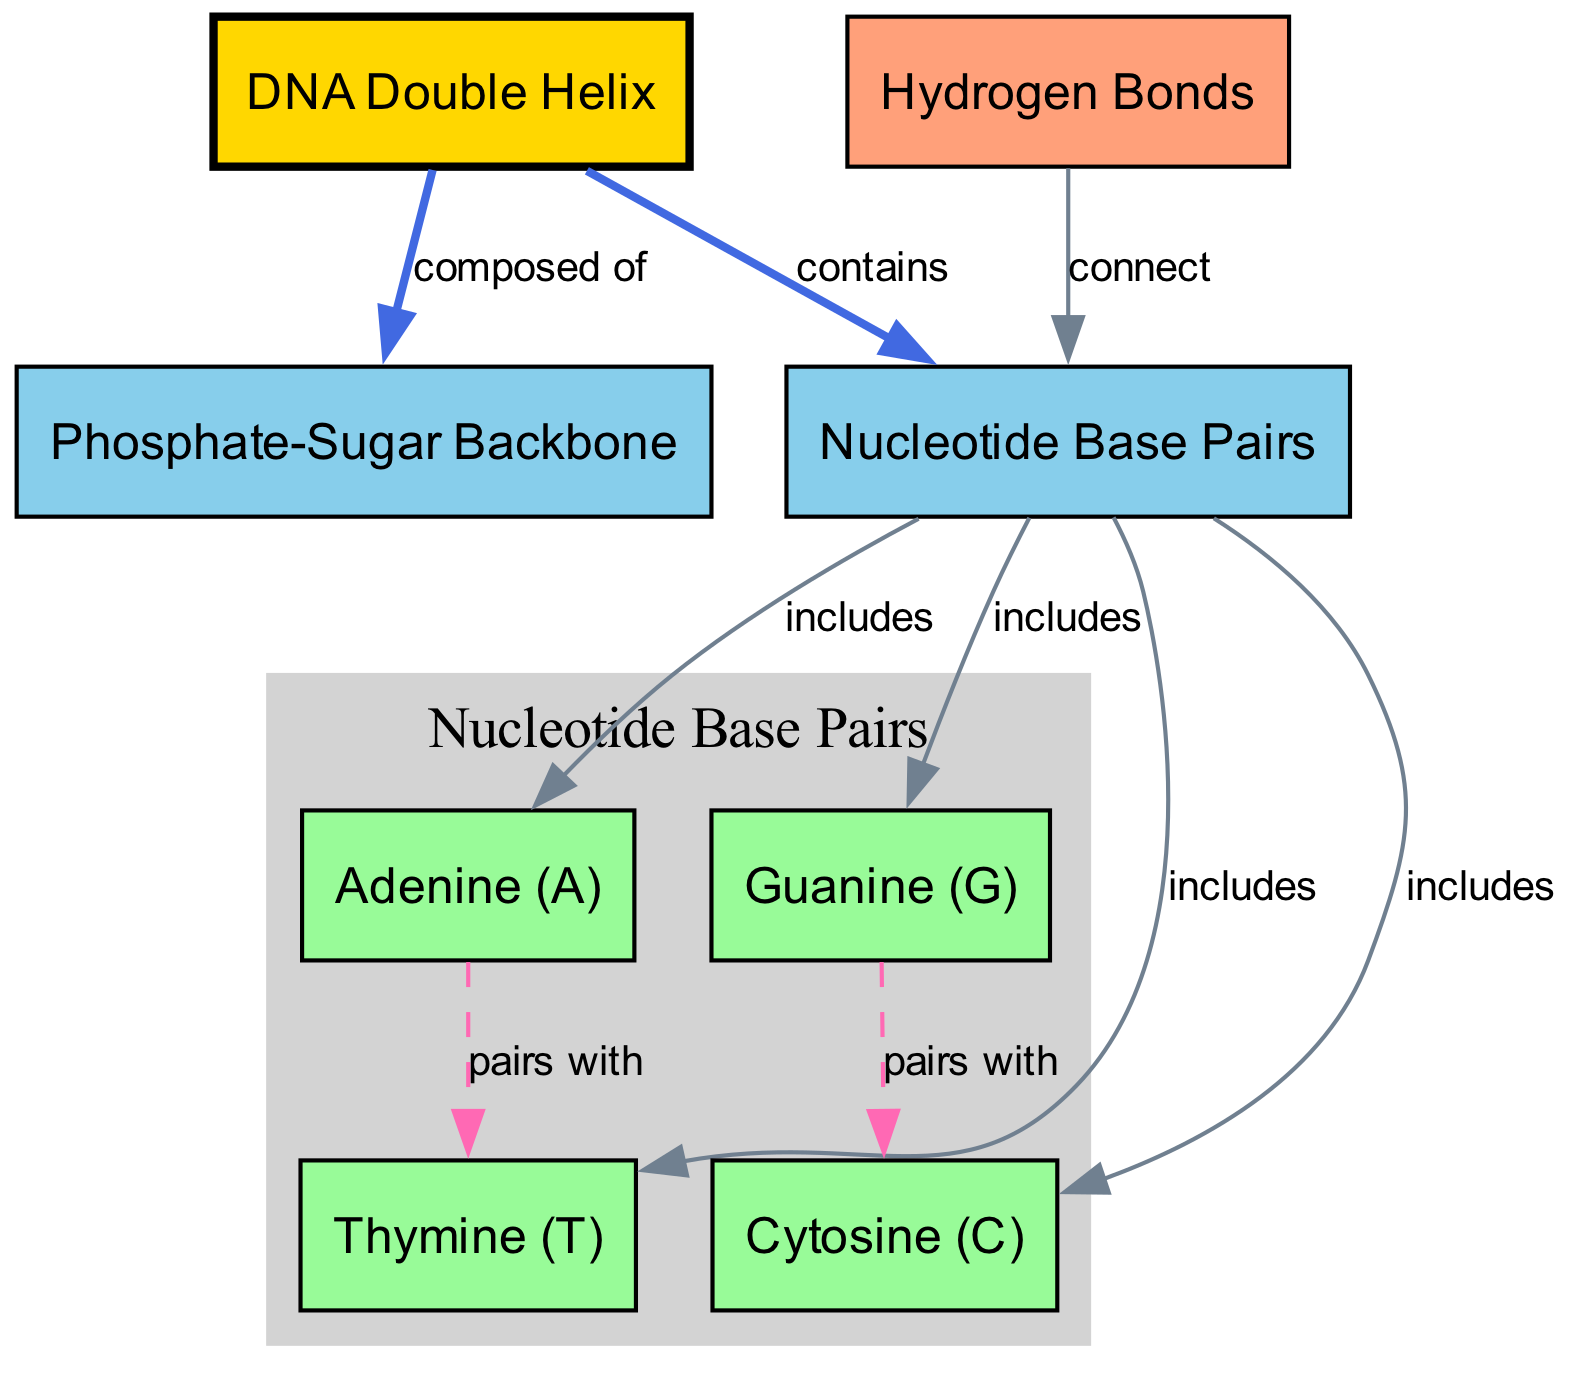What is the primary structure represented in the diagram? The diagram centers around the DNA double helix, which is clearly labeled as "DNA Double Helix" in the nodes section. This is the main focus of the diagram.
Answer: DNA double helix How many nucleotide base pairs are included in the DNA structure? The diagram specifies four types of nucleotide base pairs: adenine, thymine, guanine, and cytosine. By counting these labels, we confirm there are four base pairs.
Answer: 4 What pairs with adenine in the base pairing? According to the edge connecting adenine to thymine, adenine (A) specifically pairs with thymine (T). The relationship of pairing is directly stated in the diagram.
Answer: Thymine What connects the nucleotide base pairs together? The label "Hydrogen Bonds" in the diagram indicates that hydrogen bonds connect the nucleotide base pairs. This label is directed to the base pairs, defining their connection.
Answer: Hydrogen bonds Which part of the DNA structure is composed of the phosphate-sugar backbone? The edge labeled "composed of" indicates that the phosphate-sugar backbone is a component of the DNA double helix. Observing the edge connection clarifies the composition.
Answer: Phosphate-sugar backbone Which bases are involved in the pairing represented by the diagram? There are two pairings depicted: adenine with thymine, and guanine with cytosine. The edges from these bases show the relationships and pairing connections.
Answer: Adenine and Thymine; Guanine and Cytosine How many edges represent relationships in the base pairs? The diagram shows three edges directly related to the pairs: adenine to thymine and guanine to cytosine. This indicates the total number of direct relationships within the base pairs.
Answer: 3 What does the diagram indicate is included in the DNA structure? The diagram indicates that nucleotide base pairs are included in the DNA structure, as explicitly stated in the edge labeled "contains". This is a crucial part of the overall representation.
Answer: Nucleotide base pairs 